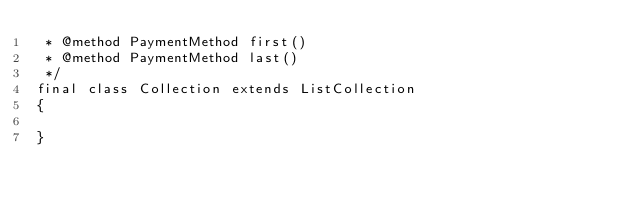<code> <loc_0><loc_0><loc_500><loc_500><_PHP_> * @method PaymentMethod first()
 * @method PaymentMethod last()
 */
final class Collection extends ListCollection
{

}
</code> 